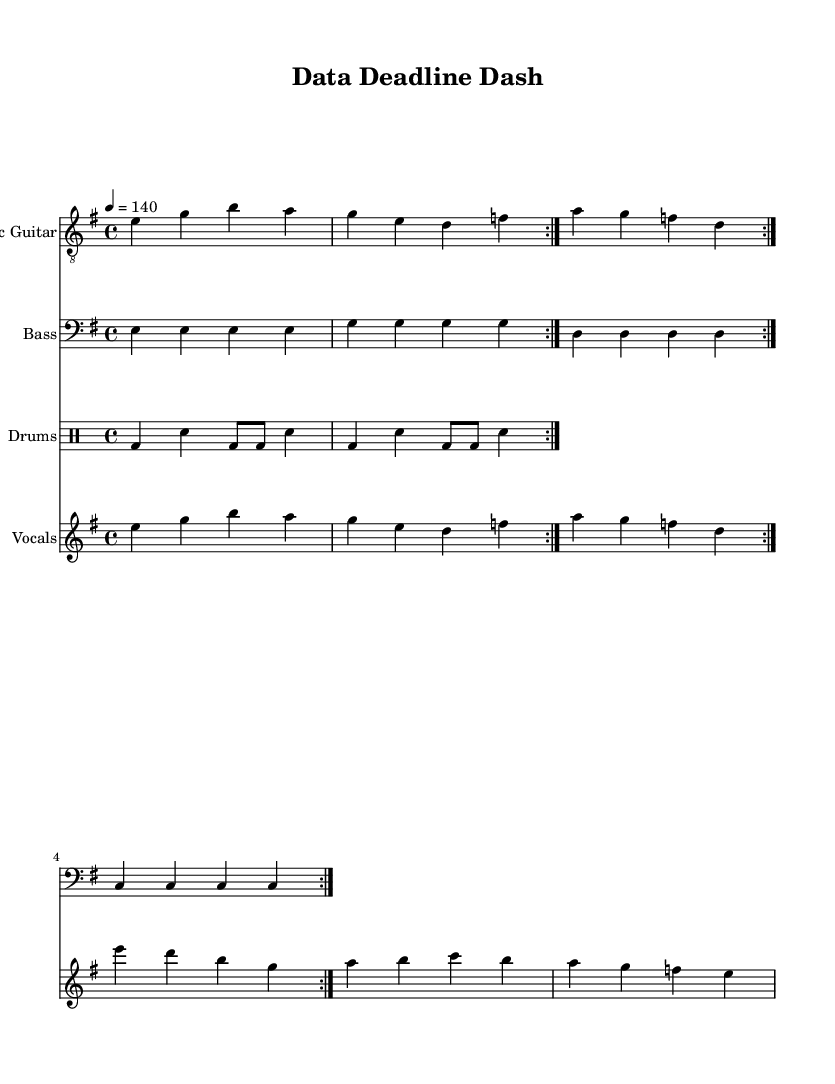What is the key signature of this music? The key signature is E minor, which is indicated by one sharp (F#).
Answer: E minor What is the time signature of this music? The time signature is 4/4, which means there are four beats in each measure and the quarter note gets one beat.
Answer: 4/4 What is the tempo marking for this piece? The tempo marking is 140 beats per minute, as shown at the beginning of the sheet music.
Answer: 140 How many bars are in the verse section? The verse section consists of 2 bars, as indicated by the repeated sections in the vocal part.
Answer: 2 In what section do the lyrics mention "Dead -- lines looming"? The lyrics mentioning "Dead -- lines looming" are part of the verse section, which addresses the theme of pressure.
Answer: Verse What type of instruments are used in this piece? The piece features electric guitar, bass, drums, and vocals, which are typical of rock music.
Answer: Electric guitar, bass, drums, vocals How does the chorus differ in rhythm compared to the verse? The chorus has a more pronounced rhythmic pattern and differs in melodic contour, enhancing the feeling of urgency associated with deadlines.
Answer: Pronounced rhythm 